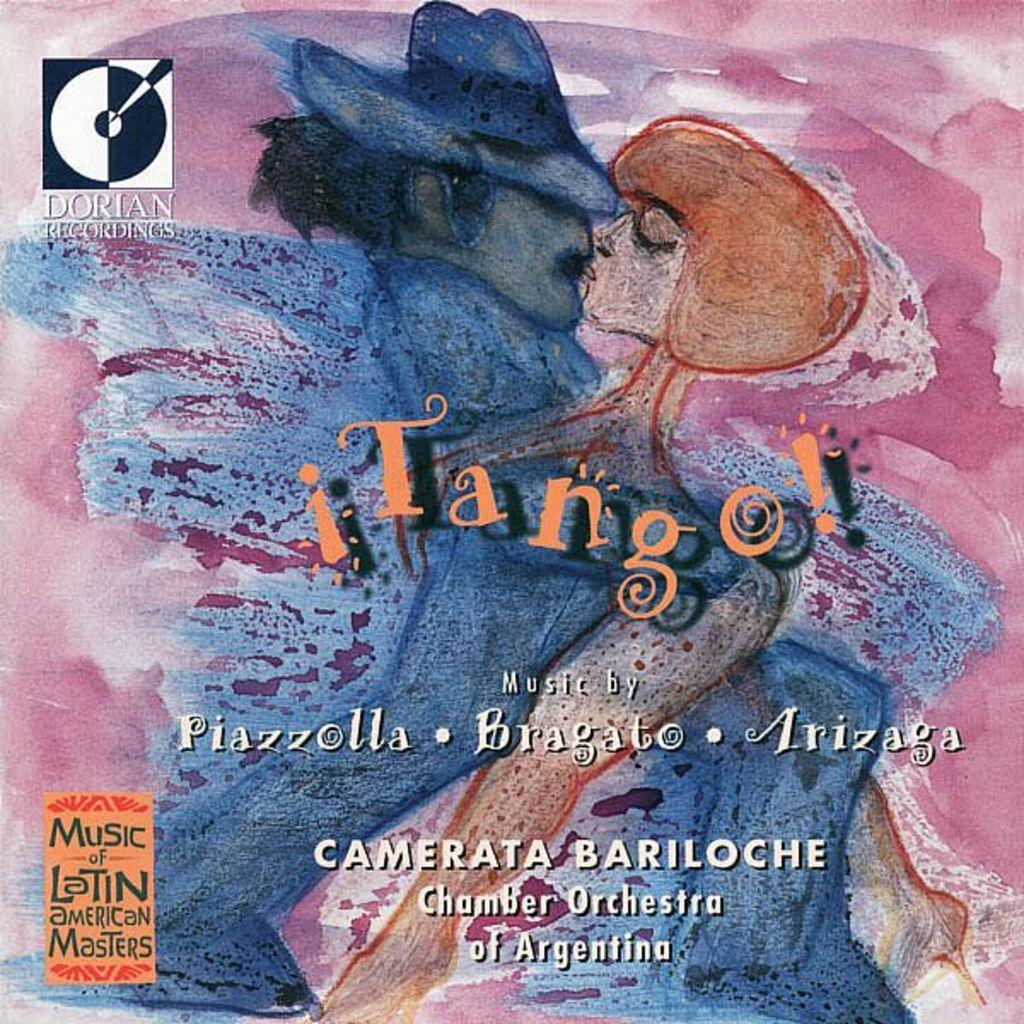Provide a one-sentence caption for the provided image. A painting for a record cover shows a man and a lady kissing and is called Tango!, music by Piazzolla, Bragato, and Arizaga. 